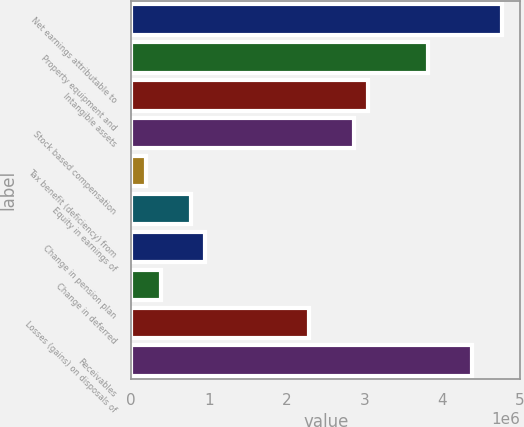Convert chart to OTSL. <chart><loc_0><loc_0><loc_500><loc_500><bar_chart><fcel>Net earnings attributable to<fcel>Property equipment and<fcel>Intangible assets<fcel>Stock based compensation<fcel>Tax benefit (deficiency) from<fcel>Equity in earnings of<fcel>Change in pension plan<fcel>Change in deferred<fcel>Losses (gains) on disposals of<fcel>Receivables<nl><fcel>4.76722e+06<fcel>3.81385e+06<fcel>3.05115e+06<fcel>2.86048e+06<fcel>191043<fcel>763065<fcel>953739<fcel>381717<fcel>2.28846e+06<fcel>4.38587e+06<nl></chart> 